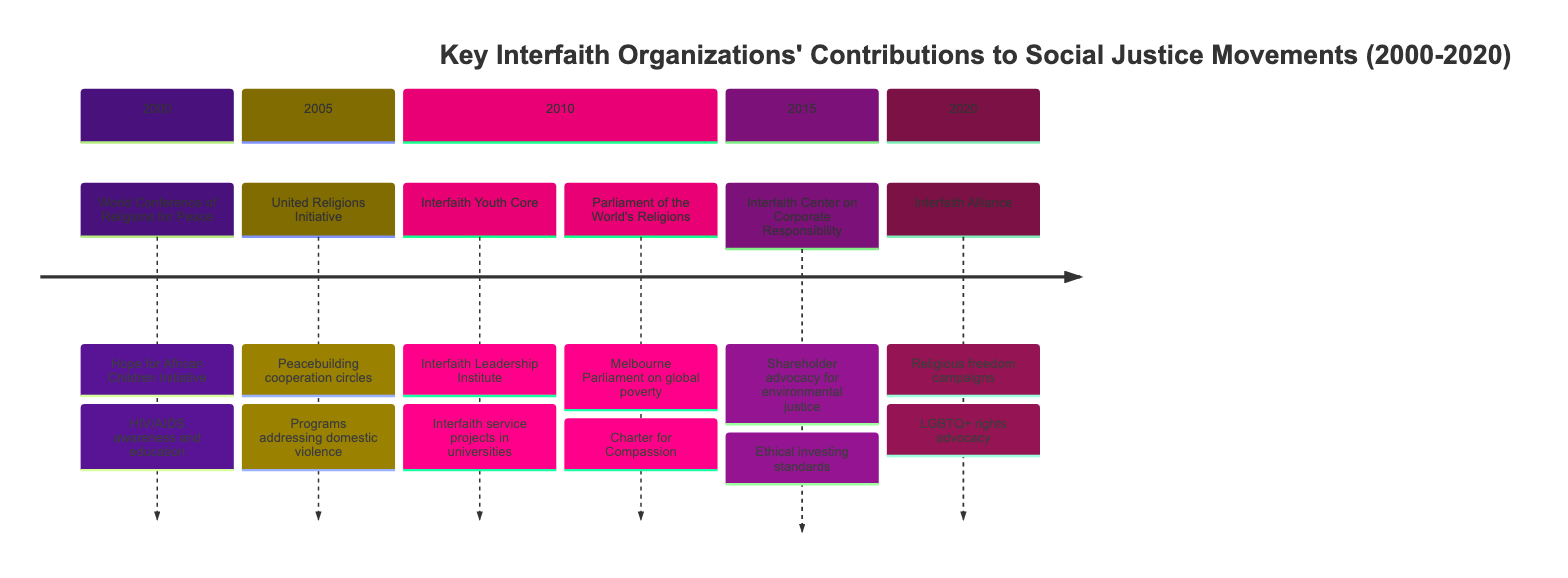What organization launched the Hope for African Children Initiative? The diagram indicates that the World Conference of Religions for Peace is responsible for launching the Hope for African Children Initiative in the year 2000.
Answer: World Conference of Religions for Peace How many organizations contributed in 2010? The diagram displays two organizations listed under the year 2010: Interfaith Youth Core and Parliament of the World's Religions. Therefore, the total number of organizations is two.
Answer: 2 Which organization conducted campaigns for religious freedom in 2020? According to the diagram, the Interfaith Alliance is the organization involved in campaigns for religious freedom and separation of church and state in 2020.
Answer: Interfaith Alliance In which year did the Interfaith Center on Corporate Responsibility contribute to environmental justice? The diagram indicates that contributions for environmental justice by the Interfaith Center on Corporate Responsibility occurred in the year 2015.
Answer: 2015 What initiative was launched in 2005 focused on peacebuilding? The United Religions Initiative initiated cooperation circles focusing on peacebuilding in the year 2005, as shown in the diagram.
Answer: Cooperation circles What focus did the Parliament of the World's Religions have during its Melbourne Parliament in 2010? The diagram states that the Parliament of the World's Religions organized the Melbourne Parliament focusing on global poverty alleviation in 2010.
Answer: Global poverty alleviation How many contributions did the Interfaith Alliance make in 2020? The diagram shows two contributions made by the Interfaith Alliance in 2020: campaigns for religious freedom and advocacy for LGBTQ+ rights, indicating that there are two contributions.
Answer: 2 Which organization aimed to promote ethical investing standards in 2015? As per the diagram, the organization focused on promoting ethical investing standards in 2015 is the Interfaith Center on Corporate Responsibility.
Answer: Interfaith Center on Corporate Responsibility What was the primary theme of UN initiatives that began in 2000? The World Conference of Religions for Peace's initiatives include the launch of the Hope for African Children Initiative, indicating that child welfare, specifically in Africa, was a primary theme in 2000.
Answer: Hope for African Children Initiative 